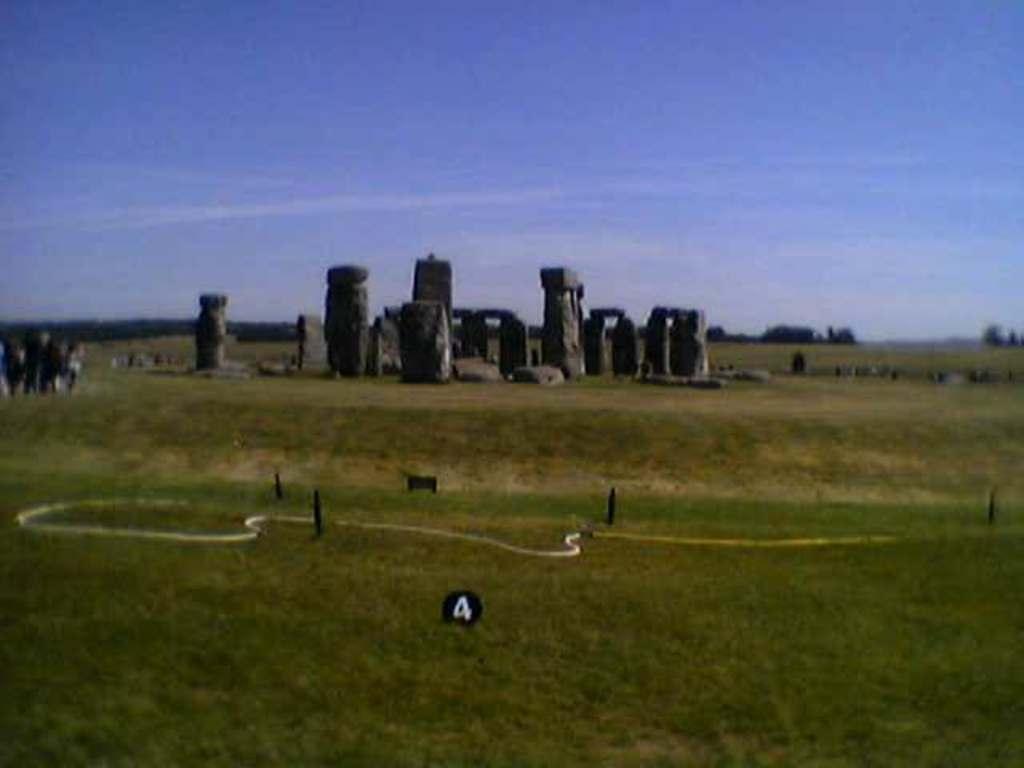Please provide a concise description of this image. In the center of the image there are stone structures. In the background of the image there is sky. At the bottom of the image there is grass. To the left side of the image there are people. 